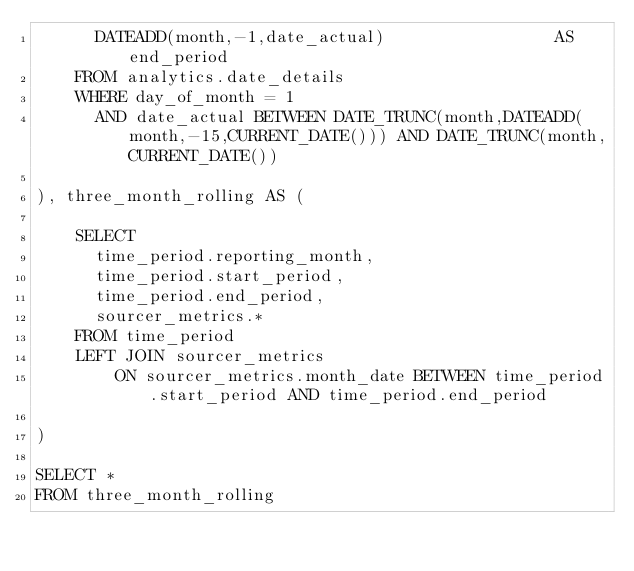Convert code to text. <code><loc_0><loc_0><loc_500><loc_500><_SQL_>      DATEADD(month,-1,date_actual)                 AS end_period          
    FROM analytics.date_details
    WHERE day_of_month = 1
      AND date_actual BETWEEN DATE_TRUNC(month,DATEADD(month,-15,CURRENT_DATE())) AND DATE_TRUNC(month,CURRENT_DATE())
  
), three_month_rolling AS (

    SELECT 
      time_period.reporting_month,
      time_period.start_period,
      time_period.end_period,
      sourcer_metrics.*
    FROM time_period
    LEFT JOIN sourcer_metrics       
        ON sourcer_metrics.month_date BETWEEN time_period.start_period AND time_period.end_period
   
)

SELECT *
FROM three_month_rolling</code> 